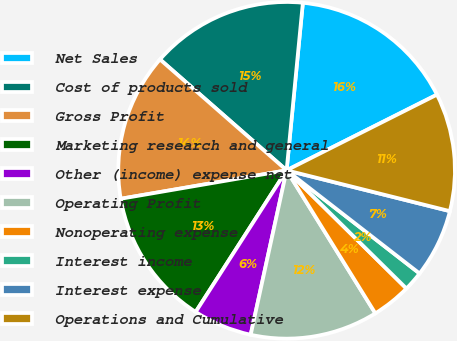Convert chart. <chart><loc_0><loc_0><loc_500><loc_500><pie_chart><fcel>Net Sales<fcel>Cost of products sold<fcel>Gross Profit<fcel>Marketing research and general<fcel>Other (income) expense net<fcel>Operating Profit<fcel>Nonoperating expense<fcel>Interest income<fcel>Interest expense<fcel>Operations and Cumulative<nl><fcel>16.04%<fcel>15.09%<fcel>14.15%<fcel>13.21%<fcel>5.66%<fcel>12.26%<fcel>3.77%<fcel>1.89%<fcel>6.6%<fcel>11.32%<nl></chart> 